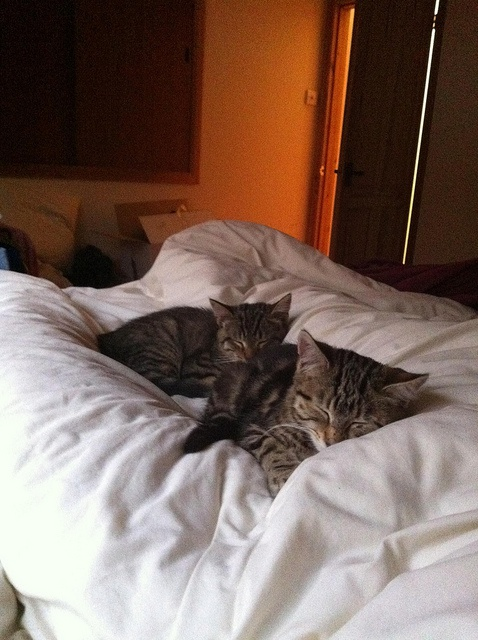Describe the objects in this image and their specific colors. I can see bed in black, lightgray, darkgray, and gray tones, cat in black, gray, and maroon tones, and cat in black, gray, and maroon tones in this image. 